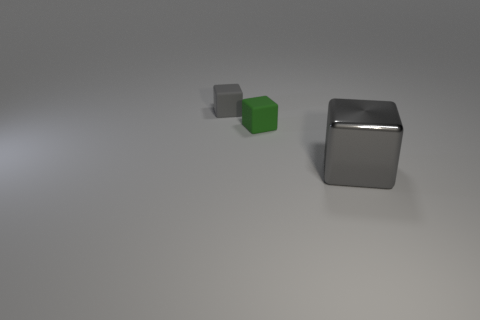How many other objects are the same size as the gray rubber object?
Make the answer very short. 1. How many small green cubes are there?
Keep it short and to the point. 1. Is the big gray block made of the same material as the tiny thing in front of the gray rubber thing?
Offer a very short reply. No. How many gray things are big objects or small cubes?
Give a very brief answer. 2. What is the size of the gray cube that is made of the same material as the green block?
Offer a terse response. Small. How many other gray objects have the same shape as the big gray thing?
Your answer should be very brief. 1. Is the number of small blocks in front of the big gray shiny object greater than the number of tiny matte cubes on the left side of the green rubber block?
Provide a succinct answer. No. Is the color of the large metal object the same as the small matte block that is right of the tiny gray block?
Your answer should be very brief. No. What material is the gray block that is the same size as the green rubber thing?
Ensure brevity in your answer.  Rubber. What number of objects are big cubes or tiny matte cubes that are right of the small gray rubber cube?
Provide a short and direct response. 2. 